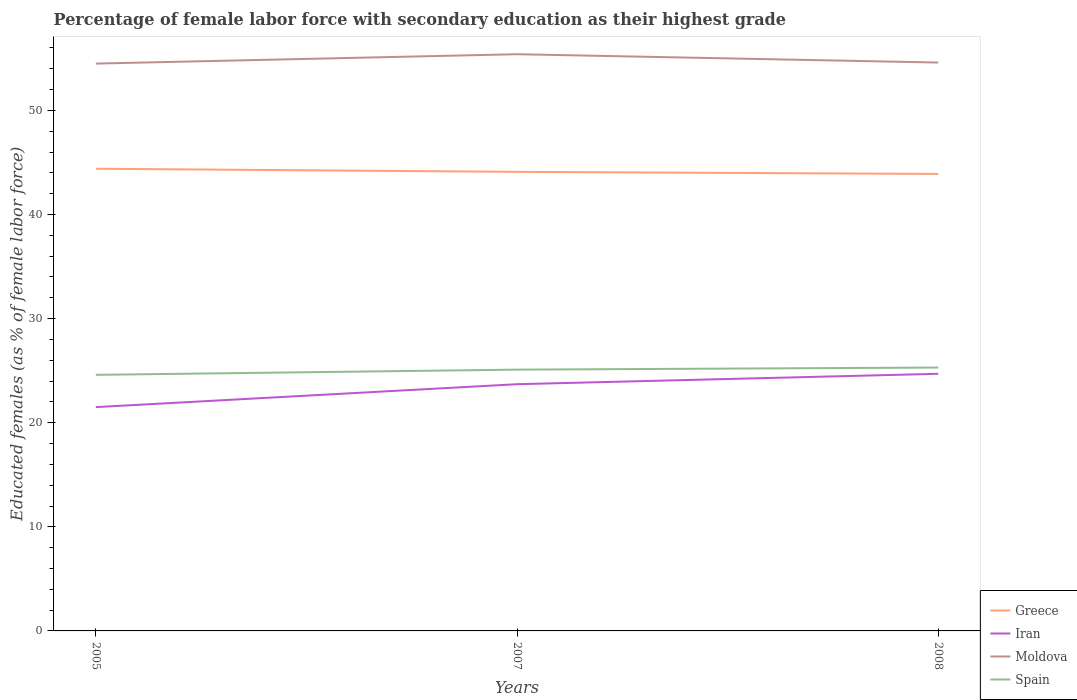How many different coloured lines are there?
Your answer should be very brief. 4. Across all years, what is the maximum percentage of female labor force with secondary education in Moldova?
Offer a terse response. 54.5. What is the difference between the highest and the second highest percentage of female labor force with secondary education in Moldova?
Keep it short and to the point. 0.9. What is the difference between the highest and the lowest percentage of female labor force with secondary education in Moldova?
Provide a short and direct response. 1. Is the percentage of female labor force with secondary education in Greece strictly greater than the percentage of female labor force with secondary education in Iran over the years?
Offer a very short reply. No. How many years are there in the graph?
Offer a terse response. 3. What is the difference between two consecutive major ticks on the Y-axis?
Ensure brevity in your answer.  10. Are the values on the major ticks of Y-axis written in scientific E-notation?
Offer a very short reply. No. Does the graph contain any zero values?
Give a very brief answer. No. Does the graph contain grids?
Provide a succinct answer. No. How are the legend labels stacked?
Your response must be concise. Vertical. What is the title of the graph?
Ensure brevity in your answer.  Percentage of female labor force with secondary education as their highest grade. Does "East Asia (developing only)" appear as one of the legend labels in the graph?
Provide a short and direct response. No. What is the label or title of the Y-axis?
Provide a short and direct response. Educated females (as % of female labor force). What is the Educated females (as % of female labor force) of Greece in 2005?
Your answer should be very brief. 44.4. What is the Educated females (as % of female labor force) of Moldova in 2005?
Offer a very short reply. 54.5. What is the Educated females (as % of female labor force) of Spain in 2005?
Your answer should be compact. 24.6. What is the Educated females (as % of female labor force) of Greece in 2007?
Your answer should be compact. 44.1. What is the Educated females (as % of female labor force) of Iran in 2007?
Offer a very short reply. 23.7. What is the Educated females (as % of female labor force) in Moldova in 2007?
Offer a very short reply. 55.4. What is the Educated females (as % of female labor force) of Spain in 2007?
Your response must be concise. 25.1. What is the Educated females (as % of female labor force) of Greece in 2008?
Keep it short and to the point. 43.9. What is the Educated females (as % of female labor force) of Iran in 2008?
Provide a short and direct response. 24.7. What is the Educated females (as % of female labor force) of Moldova in 2008?
Make the answer very short. 54.6. What is the Educated females (as % of female labor force) in Spain in 2008?
Your response must be concise. 25.3. Across all years, what is the maximum Educated females (as % of female labor force) of Greece?
Ensure brevity in your answer.  44.4. Across all years, what is the maximum Educated females (as % of female labor force) in Iran?
Your answer should be compact. 24.7. Across all years, what is the maximum Educated females (as % of female labor force) in Moldova?
Make the answer very short. 55.4. Across all years, what is the maximum Educated females (as % of female labor force) in Spain?
Offer a terse response. 25.3. Across all years, what is the minimum Educated females (as % of female labor force) in Greece?
Your answer should be very brief. 43.9. Across all years, what is the minimum Educated females (as % of female labor force) in Moldova?
Ensure brevity in your answer.  54.5. Across all years, what is the minimum Educated females (as % of female labor force) in Spain?
Give a very brief answer. 24.6. What is the total Educated females (as % of female labor force) in Greece in the graph?
Your response must be concise. 132.4. What is the total Educated females (as % of female labor force) of Iran in the graph?
Provide a short and direct response. 69.9. What is the total Educated females (as % of female labor force) of Moldova in the graph?
Keep it short and to the point. 164.5. What is the difference between the Educated females (as % of female labor force) in Spain in 2005 and that in 2007?
Keep it short and to the point. -0.5. What is the difference between the Educated females (as % of female labor force) in Moldova in 2005 and that in 2008?
Offer a terse response. -0.1. What is the difference between the Educated females (as % of female labor force) in Spain in 2005 and that in 2008?
Your answer should be compact. -0.7. What is the difference between the Educated females (as % of female labor force) of Greece in 2007 and that in 2008?
Offer a terse response. 0.2. What is the difference between the Educated females (as % of female labor force) in Iran in 2007 and that in 2008?
Ensure brevity in your answer.  -1. What is the difference between the Educated females (as % of female labor force) in Moldova in 2007 and that in 2008?
Offer a very short reply. 0.8. What is the difference between the Educated females (as % of female labor force) in Greece in 2005 and the Educated females (as % of female labor force) in Iran in 2007?
Your answer should be very brief. 20.7. What is the difference between the Educated females (as % of female labor force) of Greece in 2005 and the Educated females (as % of female labor force) of Moldova in 2007?
Keep it short and to the point. -11. What is the difference between the Educated females (as % of female labor force) in Greece in 2005 and the Educated females (as % of female labor force) in Spain in 2007?
Make the answer very short. 19.3. What is the difference between the Educated females (as % of female labor force) of Iran in 2005 and the Educated females (as % of female labor force) of Moldova in 2007?
Keep it short and to the point. -33.9. What is the difference between the Educated females (as % of female labor force) of Iran in 2005 and the Educated females (as % of female labor force) of Spain in 2007?
Make the answer very short. -3.6. What is the difference between the Educated females (as % of female labor force) of Moldova in 2005 and the Educated females (as % of female labor force) of Spain in 2007?
Your response must be concise. 29.4. What is the difference between the Educated females (as % of female labor force) of Greece in 2005 and the Educated females (as % of female labor force) of Iran in 2008?
Give a very brief answer. 19.7. What is the difference between the Educated females (as % of female labor force) in Greece in 2005 and the Educated females (as % of female labor force) in Moldova in 2008?
Provide a short and direct response. -10.2. What is the difference between the Educated females (as % of female labor force) in Greece in 2005 and the Educated females (as % of female labor force) in Spain in 2008?
Offer a very short reply. 19.1. What is the difference between the Educated females (as % of female labor force) in Iran in 2005 and the Educated females (as % of female labor force) in Moldova in 2008?
Keep it short and to the point. -33.1. What is the difference between the Educated females (as % of female labor force) in Iran in 2005 and the Educated females (as % of female labor force) in Spain in 2008?
Provide a succinct answer. -3.8. What is the difference between the Educated females (as % of female labor force) of Moldova in 2005 and the Educated females (as % of female labor force) of Spain in 2008?
Provide a succinct answer. 29.2. What is the difference between the Educated females (as % of female labor force) of Greece in 2007 and the Educated females (as % of female labor force) of Iran in 2008?
Make the answer very short. 19.4. What is the difference between the Educated females (as % of female labor force) in Greece in 2007 and the Educated females (as % of female labor force) in Moldova in 2008?
Provide a short and direct response. -10.5. What is the difference between the Educated females (as % of female labor force) of Greece in 2007 and the Educated females (as % of female labor force) of Spain in 2008?
Your answer should be compact. 18.8. What is the difference between the Educated females (as % of female labor force) in Iran in 2007 and the Educated females (as % of female labor force) in Moldova in 2008?
Provide a succinct answer. -30.9. What is the difference between the Educated females (as % of female labor force) of Iran in 2007 and the Educated females (as % of female labor force) of Spain in 2008?
Provide a short and direct response. -1.6. What is the difference between the Educated females (as % of female labor force) of Moldova in 2007 and the Educated females (as % of female labor force) of Spain in 2008?
Give a very brief answer. 30.1. What is the average Educated females (as % of female labor force) of Greece per year?
Keep it short and to the point. 44.13. What is the average Educated females (as % of female labor force) in Iran per year?
Your answer should be compact. 23.3. What is the average Educated females (as % of female labor force) in Moldova per year?
Provide a succinct answer. 54.83. In the year 2005, what is the difference between the Educated females (as % of female labor force) of Greece and Educated females (as % of female labor force) of Iran?
Your answer should be very brief. 22.9. In the year 2005, what is the difference between the Educated females (as % of female labor force) in Greece and Educated females (as % of female labor force) in Spain?
Offer a very short reply. 19.8. In the year 2005, what is the difference between the Educated females (as % of female labor force) in Iran and Educated females (as % of female labor force) in Moldova?
Make the answer very short. -33. In the year 2005, what is the difference between the Educated females (as % of female labor force) of Iran and Educated females (as % of female labor force) of Spain?
Make the answer very short. -3.1. In the year 2005, what is the difference between the Educated females (as % of female labor force) of Moldova and Educated females (as % of female labor force) of Spain?
Provide a short and direct response. 29.9. In the year 2007, what is the difference between the Educated females (as % of female labor force) in Greece and Educated females (as % of female labor force) in Iran?
Keep it short and to the point. 20.4. In the year 2007, what is the difference between the Educated females (as % of female labor force) of Iran and Educated females (as % of female labor force) of Moldova?
Your answer should be compact. -31.7. In the year 2007, what is the difference between the Educated females (as % of female labor force) of Moldova and Educated females (as % of female labor force) of Spain?
Your answer should be very brief. 30.3. In the year 2008, what is the difference between the Educated females (as % of female labor force) of Greece and Educated females (as % of female labor force) of Iran?
Make the answer very short. 19.2. In the year 2008, what is the difference between the Educated females (as % of female labor force) of Greece and Educated females (as % of female labor force) of Spain?
Give a very brief answer. 18.6. In the year 2008, what is the difference between the Educated females (as % of female labor force) of Iran and Educated females (as % of female labor force) of Moldova?
Ensure brevity in your answer.  -29.9. In the year 2008, what is the difference between the Educated females (as % of female labor force) of Moldova and Educated females (as % of female labor force) of Spain?
Your response must be concise. 29.3. What is the ratio of the Educated females (as % of female labor force) of Greece in 2005 to that in 2007?
Ensure brevity in your answer.  1.01. What is the ratio of the Educated females (as % of female labor force) of Iran in 2005 to that in 2007?
Keep it short and to the point. 0.91. What is the ratio of the Educated females (as % of female labor force) in Moldova in 2005 to that in 2007?
Provide a short and direct response. 0.98. What is the ratio of the Educated females (as % of female labor force) of Spain in 2005 to that in 2007?
Offer a very short reply. 0.98. What is the ratio of the Educated females (as % of female labor force) in Greece in 2005 to that in 2008?
Offer a very short reply. 1.01. What is the ratio of the Educated females (as % of female labor force) in Iran in 2005 to that in 2008?
Your answer should be compact. 0.87. What is the ratio of the Educated females (as % of female labor force) of Spain in 2005 to that in 2008?
Give a very brief answer. 0.97. What is the ratio of the Educated females (as % of female labor force) in Iran in 2007 to that in 2008?
Offer a very short reply. 0.96. What is the ratio of the Educated females (as % of female labor force) in Moldova in 2007 to that in 2008?
Your answer should be very brief. 1.01. What is the difference between the highest and the second highest Educated females (as % of female labor force) of Spain?
Offer a terse response. 0.2. What is the difference between the highest and the lowest Educated females (as % of female labor force) of Greece?
Offer a terse response. 0.5. What is the difference between the highest and the lowest Educated females (as % of female labor force) in Iran?
Give a very brief answer. 3.2. What is the difference between the highest and the lowest Educated females (as % of female labor force) in Spain?
Provide a short and direct response. 0.7. 